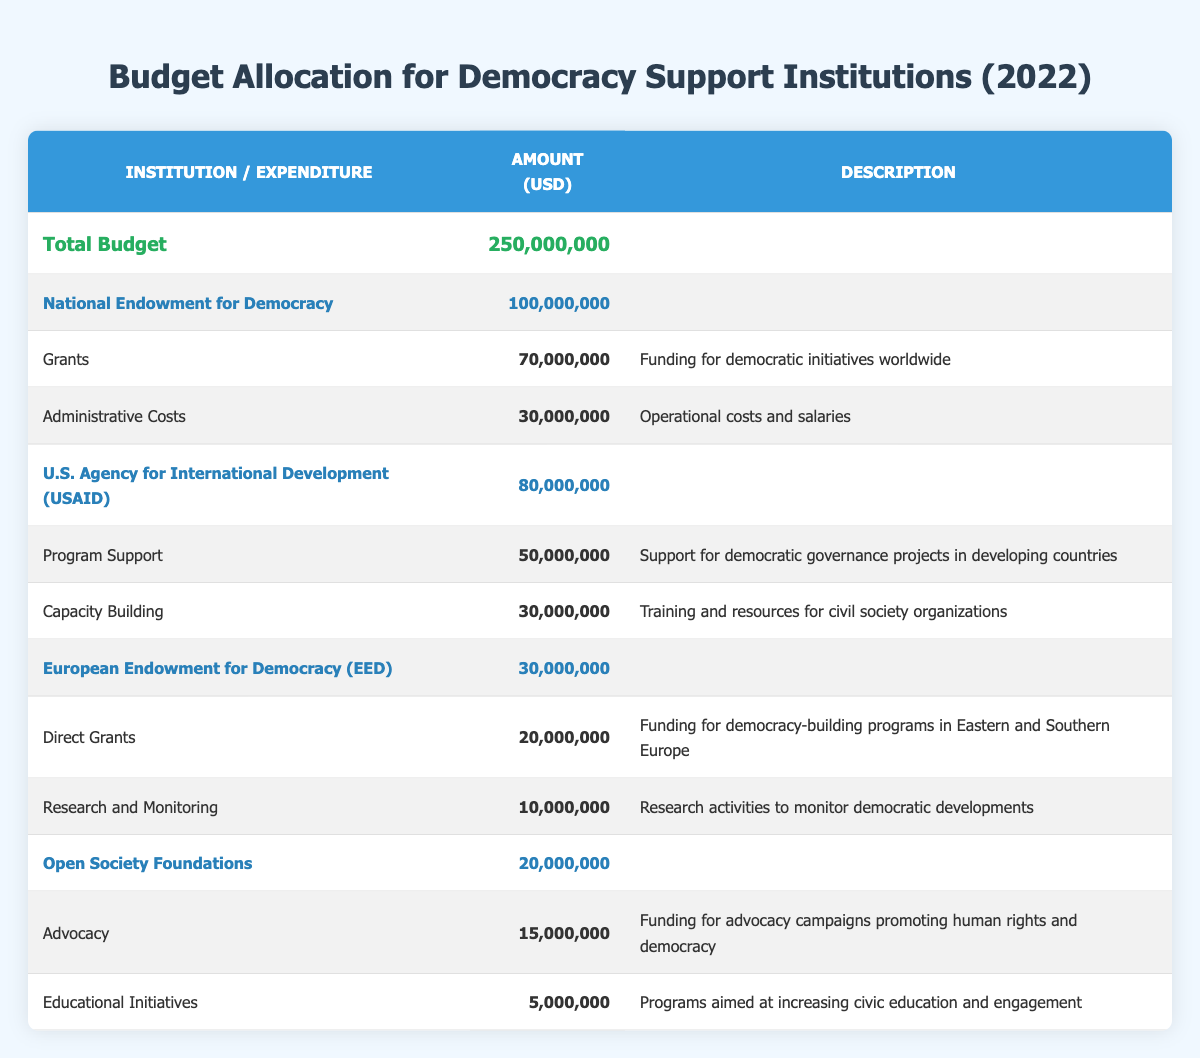What is the total budget allocated for public institutions supporting democracy in 2022? The total budget is listed at the top of the table under "Total Budget," which shows an amount of 250,000,000 USD.
Answer: 250,000,000 USD How much budget is allocated to the National Endowment for Democracy? The budget allocation for the National Endowment for Democracy is directly presented under its name in the table, which states 100,000,000 USD.
Answer: 100,000,000 USD What percentage of the total budget is allocated to the U.S. Agency for International Development (USAID)? The budget allocation for USAID is 80,000,000 USD. To find the percentage, we calculate (80,000,000 / 250,000,000) * 100, which results in 32%.
Answer: 32% Is the expenditure for Grants from the National Endowment for Democracy greater than the expenditure for Program Support from USAID? The table shows that the Grants from the National Endowment for Democracy amount to 70,000,000 USD, while Program Support from USAID is 50,000,000 USD. Since 70,000,000 is greater than 50,000,000, the answer is Yes.
Answer: Yes What is the total expenditure for all public institutions listed in the table? To find the total expenditure, we need to sum all the expenditures from each institution: 70,000,000 (NED) + 30,000,000 (NED) + 50,000,000 (USAID) + 30,000,000 (USAID) + 20,000,000 (EED) + 10,000,000 (EED) + 15,000,000 (OSF) + 5,000,000 (OSF) = 330,000,000 USD.
Answer: 330,000,000 USD What is the average budget allocation for the four public institutions? The budget allocations for the institutions are 100,000,000 (NED) + 80,000,000 (USAID) + 30,000,000 (EED) + 20,000,000 (OSF) = 230,000,000 USD. Dividing this by the number of institutions (4) gives an average of 57,500,000 USD.
Answer: 57,500,000 USD Does the Open Society Foundations have more total expenditures than the European Endowment for Democracy? The expenditures for Open Society Foundations are 15,000,000 (Advocacy) + 5,000,000 (Educational Initiatives) = 20,000,000 USD. For the European Endowment for Democracy, the expenditures are 20,000,000 (Direct Grants) + 10,000,000 (Research and Monitoring) = 30,000,000 USD. Since 20,000,000 is less than 30,000,000, the answer is No.
Answer: No How much more funding does the National Endowment for Democracy allocate to Grants than the European Endowment for Democracy allocates to Direct Grants? The National Endowment for Democracy allocates 70,000,000 USD to Grants, while the European Endowment for Democracy allocates 20,000,000 USD to Direct Grants. The difference is 70,000,000 - 20,000,000 = 50,000,000 USD.
Answer: 50,000,000 USD 